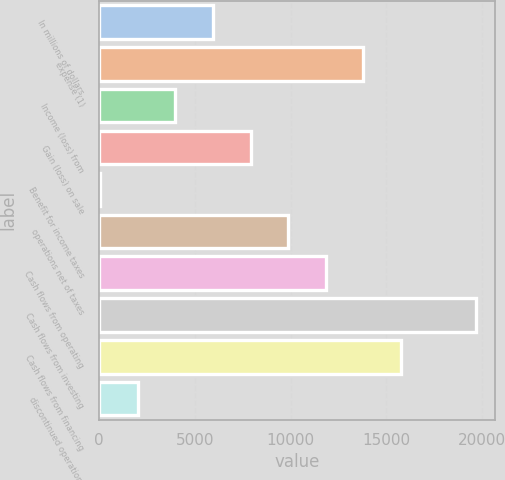Convert chart. <chart><loc_0><loc_0><loc_500><loc_500><bar_chart><fcel>In millions of dollars<fcel>expense (1)<fcel>Income (loss) from<fcel>Gain (loss) on sale<fcel>Benefit for income taxes<fcel>operations net of taxes<fcel>Cash flows from operating<fcel>Cash flows from investing<fcel>Cash flows from financing<fcel>discontinued operations<nl><fcel>5954.5<fcel>13788.5<fcel>3996<fcel>7913<fcel>79<fcel>9871.5<fcel>11830<fcel>19664<fcel>15747<fcel>2037.5<nl></chart> 